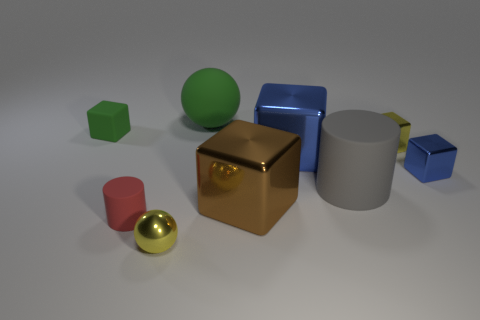Subtract all yellow blocks. How many blocks are left? 4 Subtract all large brown cubes. How many cubes are left? 4 Subtract all cyan cubes. Subtract all blue balls. How many cubes are left? 5 Add 1 gray matte cylinders. How many objects exist? 10 Subtract all cylinders. How many objects are left? 7 Subtract all small gray rubber spheres. Subtract all tiny metallic spheres. How many objects are left? 8 Add 2 tiny yellow cubes. How many tiny yellow cubes are left? 3 Add 4 large yellow metal cubes. How many large yellow metal cubes exist? 4 Subtract 0 cyan blocks. How many objects are left? 9 